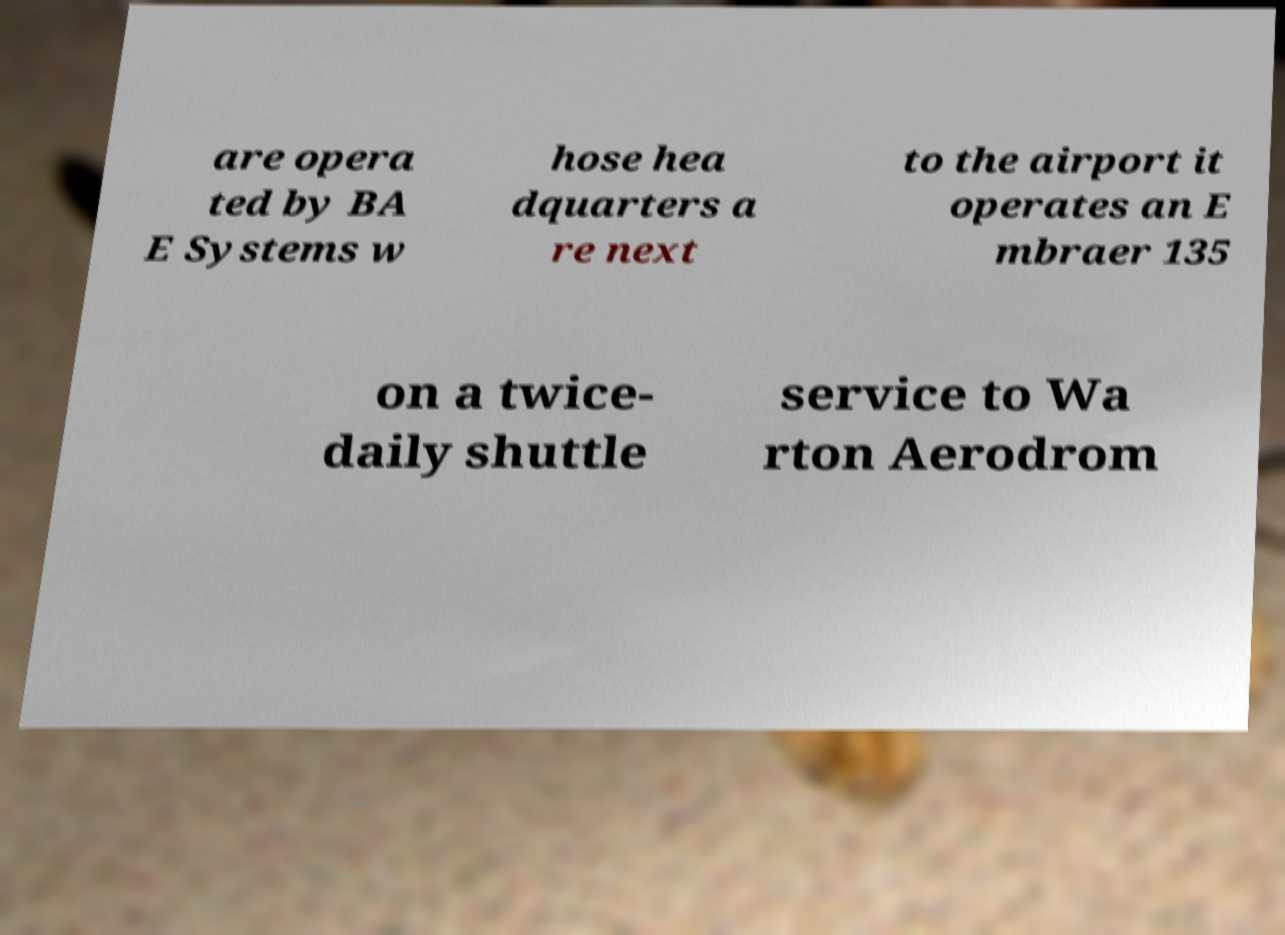What messages or text are displayed in this image? I need them in a readable, typed format. are opera ted by BA E Systems w hose hea dquarters a re next to the airport it operates an E mbraer 135 on a twice- daily shuttle service to Wa rton Aerodrom 